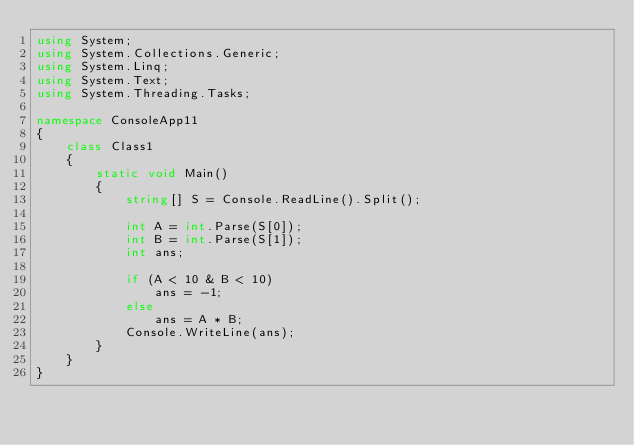<code> <loc_0><loc_0><loc_500><loc_500><_C#_>using System;
using System.Collections.Generic;
using System.Linq;
using System.Text;
using System.Threading.Tasks;

namespace ConsoleApp11
{
    class Class1
    {
        static void Main()
        {
            string[] S = Console.ReadLine().Split();

            int A = int.Parse(S[0]);
            int B = int.Parse(S[1]);
            int ans;

            if (A < 10 & B < 10)
                ans = -1;
            else
                ans = A * B;
            Console.WriteLine(ans);
        }
    }
}</code> 